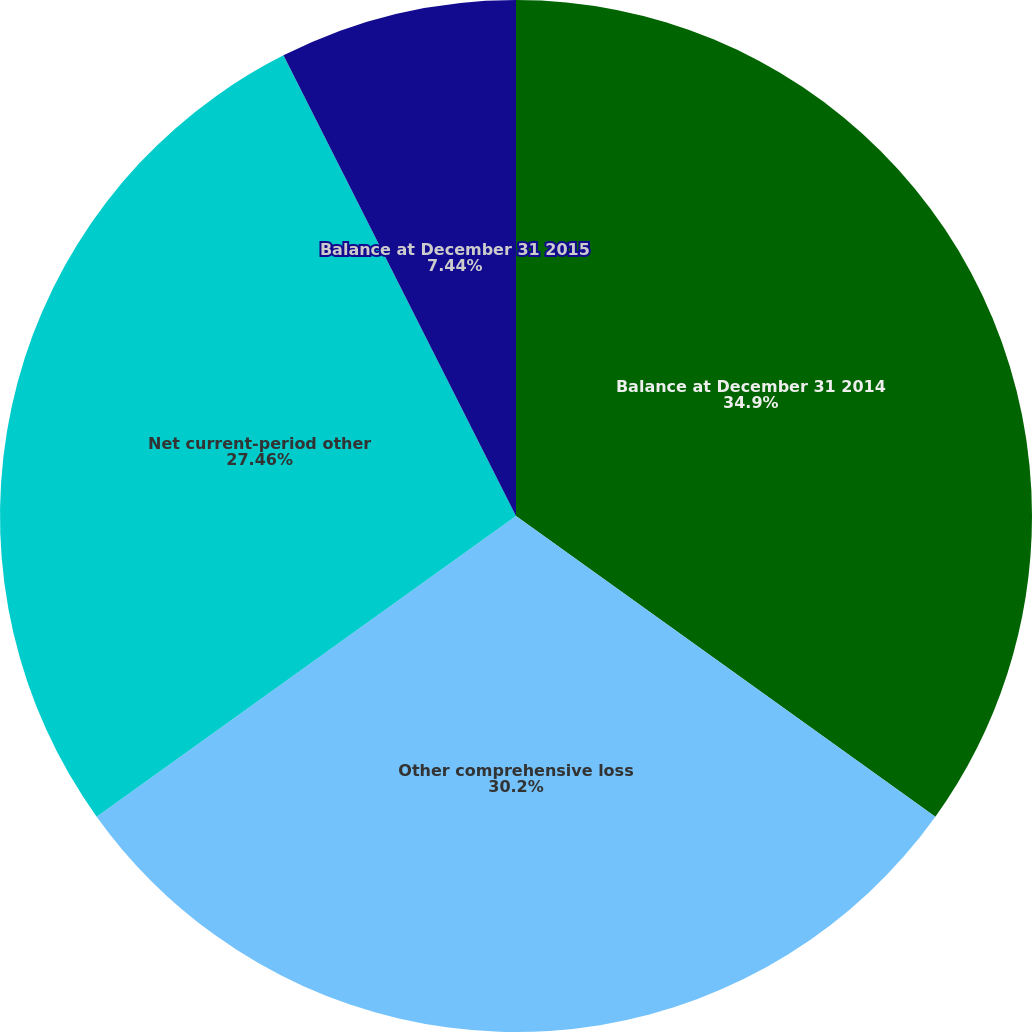<chart> <loc_0><loc_0><loc_500><loc_500><pie_chart><fcel>Balance at December 31 2014<fcel>Other comprehensive loss<fcel>Net current-period other<fcel>Balance at December 31 2015<nl><fcel>34.9%<fcel>30.2%<fcel>27.46%<fcel>7.44%<nl></chart> 